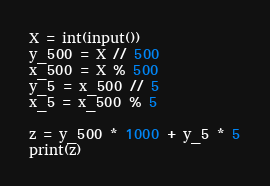<code> <loc_0><loc_0><loc_500><loc_500><_Python_>X = int(input())
y_500 = X // 500
x_500 = X % 500
y_5 = x_500 // 5
x_5 = x_500 % 5

z = y_500 * 1000 + y_5 * 5
print(z)</code> 